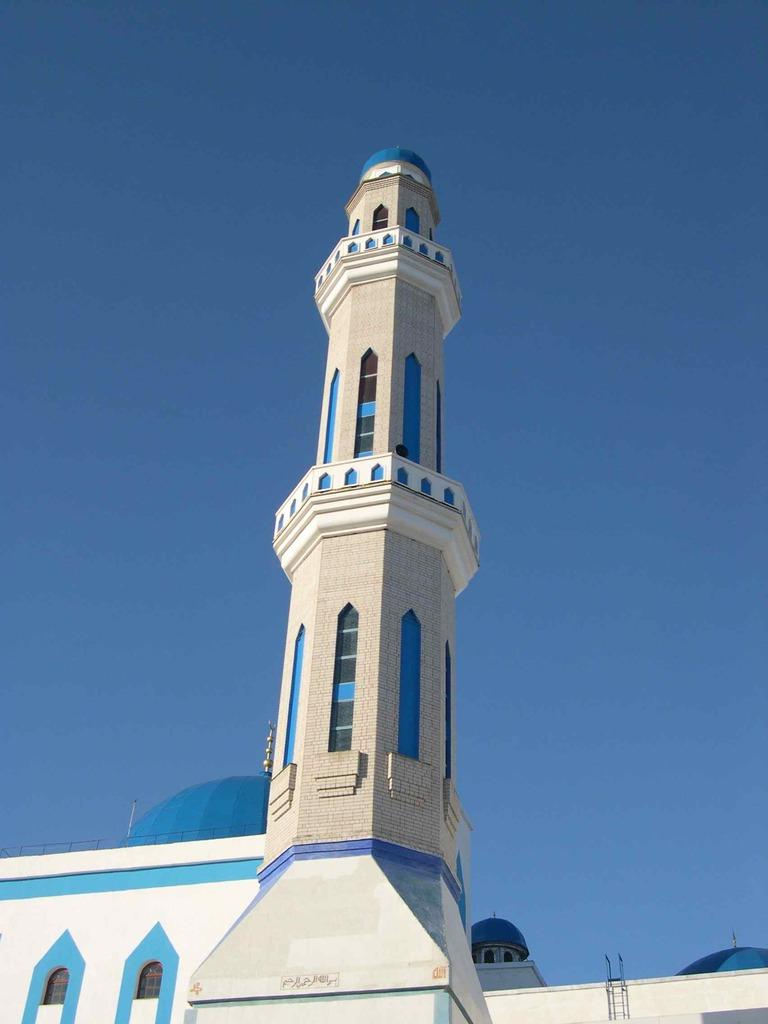What type of structure is visible in the image? There is a building in the image. What color is the sky in the image? The sky is blue in the image. Can you tell me how many leaves are on the clover in the image? There is no clover present in the image, so it is not possible to determine the number of leaves on a clover. 